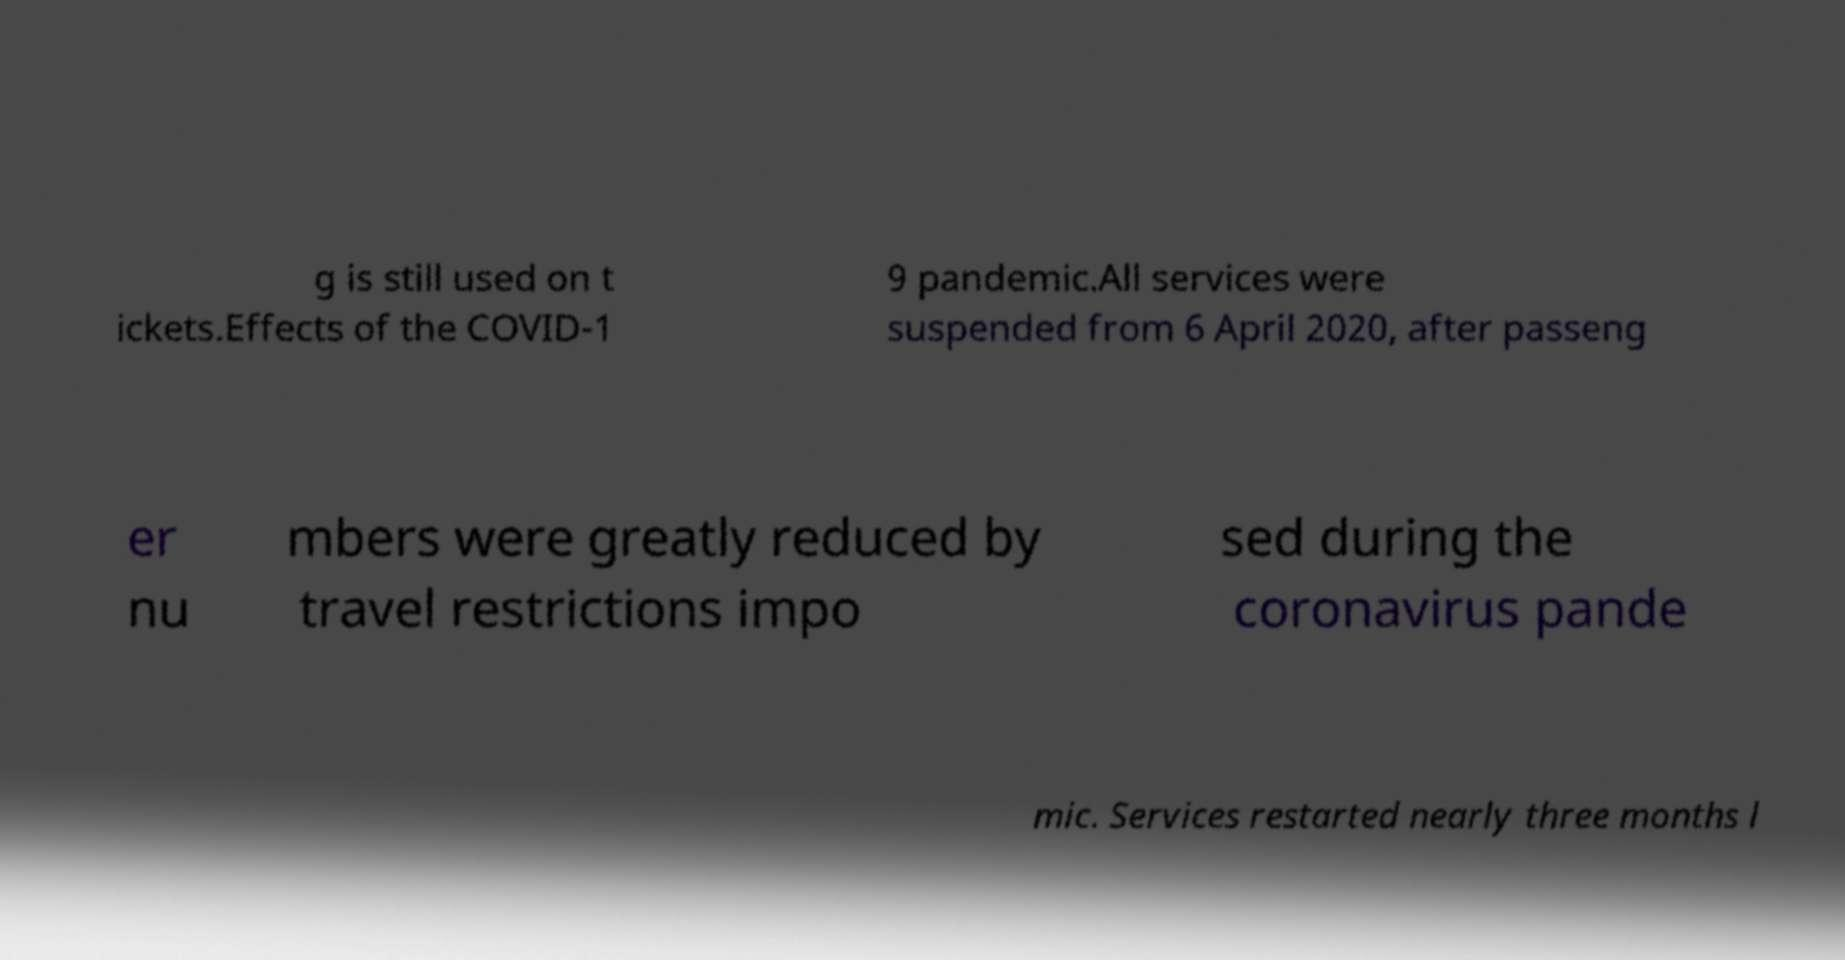Please read and relay the text visible in this image. What does it say? g is still used on t ickets.Effects of the COVID-1 9 pandemic.All services were suspended from 6 April 2020, after passeng er nu mbers were greatly reduced by travel restrictions impo sed during the coronavirus pande mic. Services restarted nearly three months l 